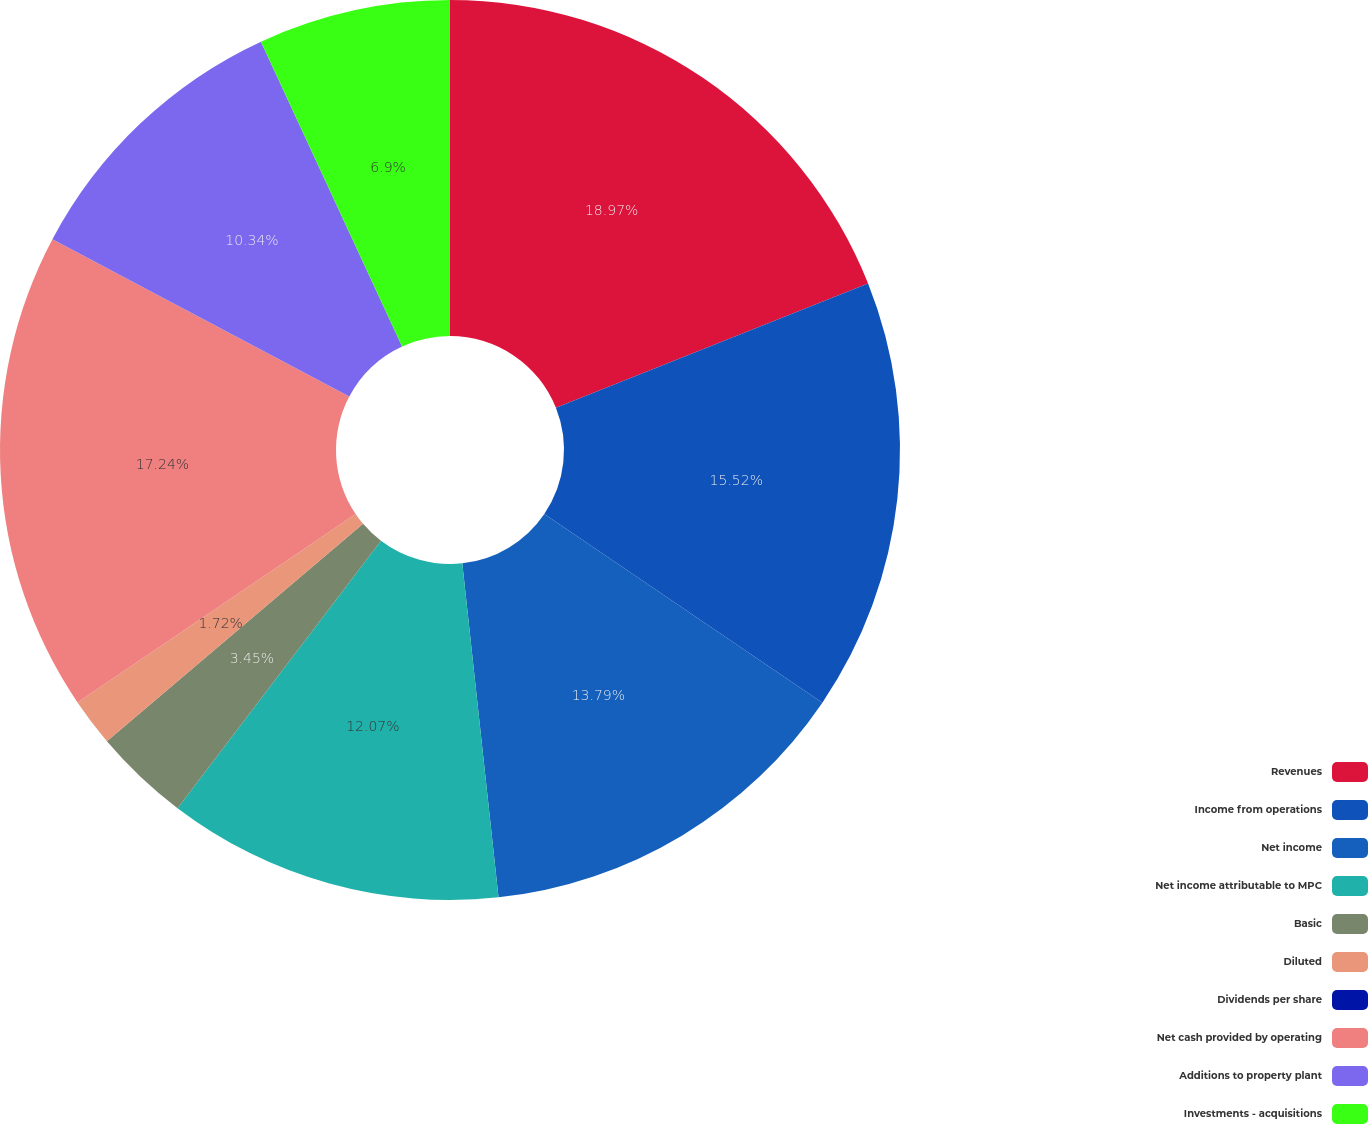Convert chart. <chart><loc_0><loc_0><loc_500><loc_500><pie_chart><fcel>Revenues<fcel>Income from operations<fcel>Net income<fcel>Net income attributable to MPC<fcel>Basic<fcel>Diluted<fcel>Dividends per share<fcel>Net cash provided by operating<fcel>Additions to property plant<fcel>Investments - acquisitions<nl><fcel>18.97%<fcel>15.52%<fcel>13.79%<fcel>12.07%<fcel>3.45%<fcel>1.72%<fcel>0.0%<fcel>17.24%<fcel>10.34%<fcel>6.9%<nl></chart> 